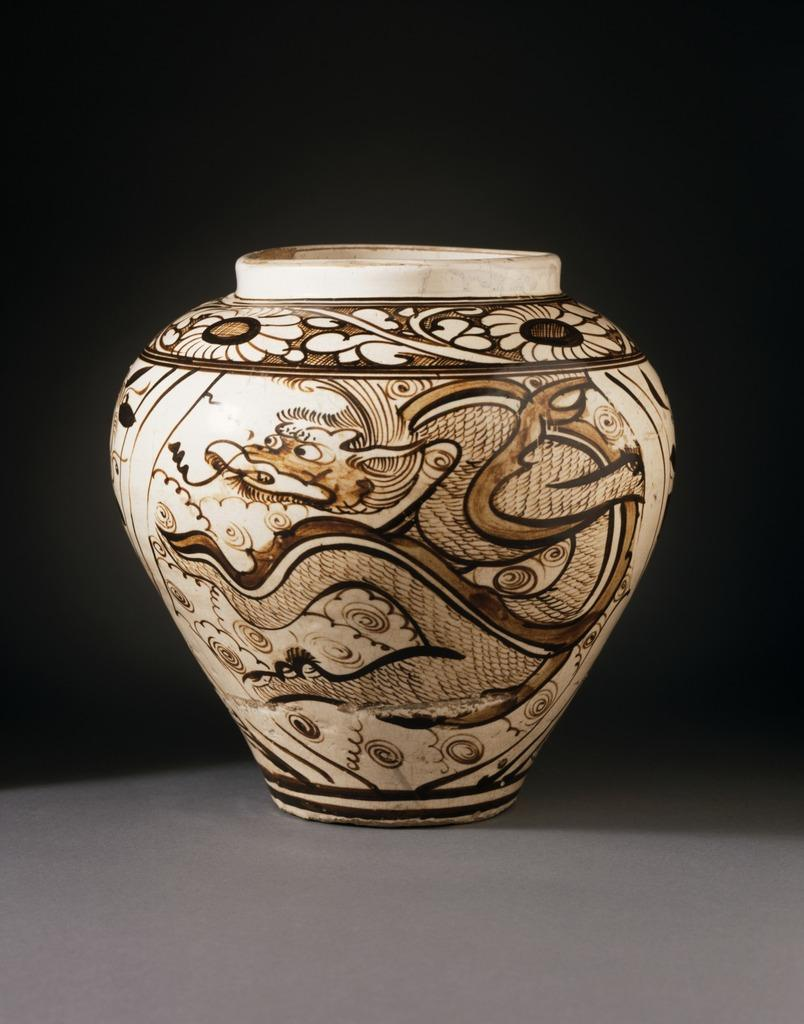What is the main object in the image? There is a pot in the image. What is depicted on the pot? There is a painting on the pot. How would you describe the overall appearance of the image? The background of the image is dark. How many cents can be seen on the pot in the image? There are no cents depicted on the pot in the image. What type of crowd is visible in the background of the image? There is no crowd visible in the image, as the background is dark. 